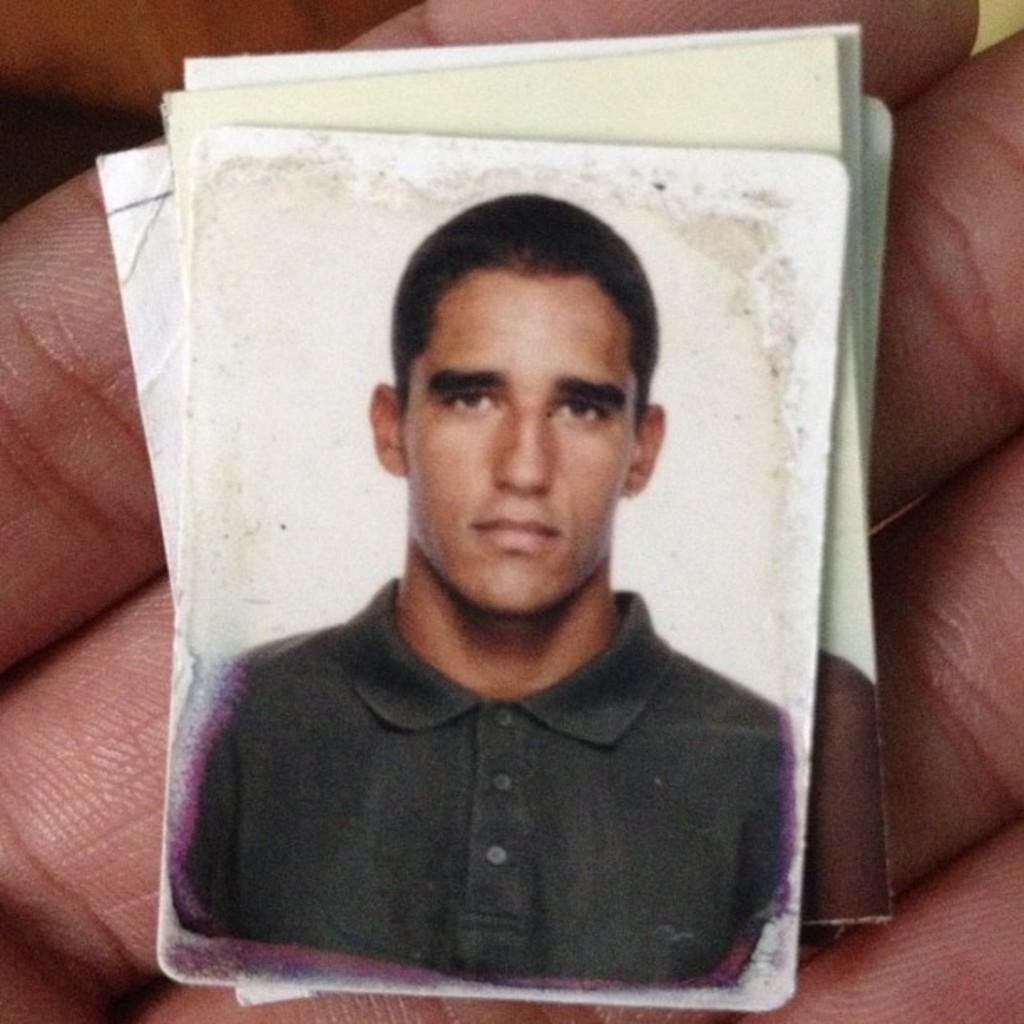What can be seen on the person's fingers in the image? There is a photograph on the fingers in the image. What is depicted in the photograph? The photograph depicts a man. What is the man in the photograph wearing? The man in the photograph is wearing a t-shirt. What else is visible in the image besides the person's fingers and the photograph? There are papers visible in the image. What type of yarn is the man in the photograph using to create a sculpture? There is no yarn or sculpture present in the image; the photograph depicts a man wearing a t-shirt. Can you see any ants crawling on the person's fingers in the image? There are no ants visible in the image; the focus is on the photograph on the person's fingers. 